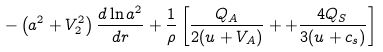<formula> <loc_0><loc_0><loc_500><loc_500>- \left ( a ^ { 2 } + V _ { 2 } ^ { 2 } \right ) \frac { d \ln a ^ { 2 } } { d r } + \frac { 1 } { \rho } \left [ \frac { Q _ { A } } { 2 ( u + V _ { A } ) } + + \frac { 4 Q _ { S } } { 3 ( u + c _ { s } ) } \right ]</formula> 